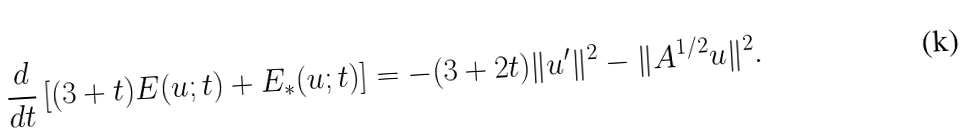Convert formula to latex. <formula><loc_0><loc_0><loc_500><loc_500>\frac { d } { d t } \left [ ( 3 + t ) E ( u ; t ) + E _ { * } ( u ; t ) \right ] = - ( 3 + 2 t ) \| u ^ { \prime } \| ^ { 2 } - \| A ^ { 1 / 2 } u \| ^ { 2 } .</formula> 